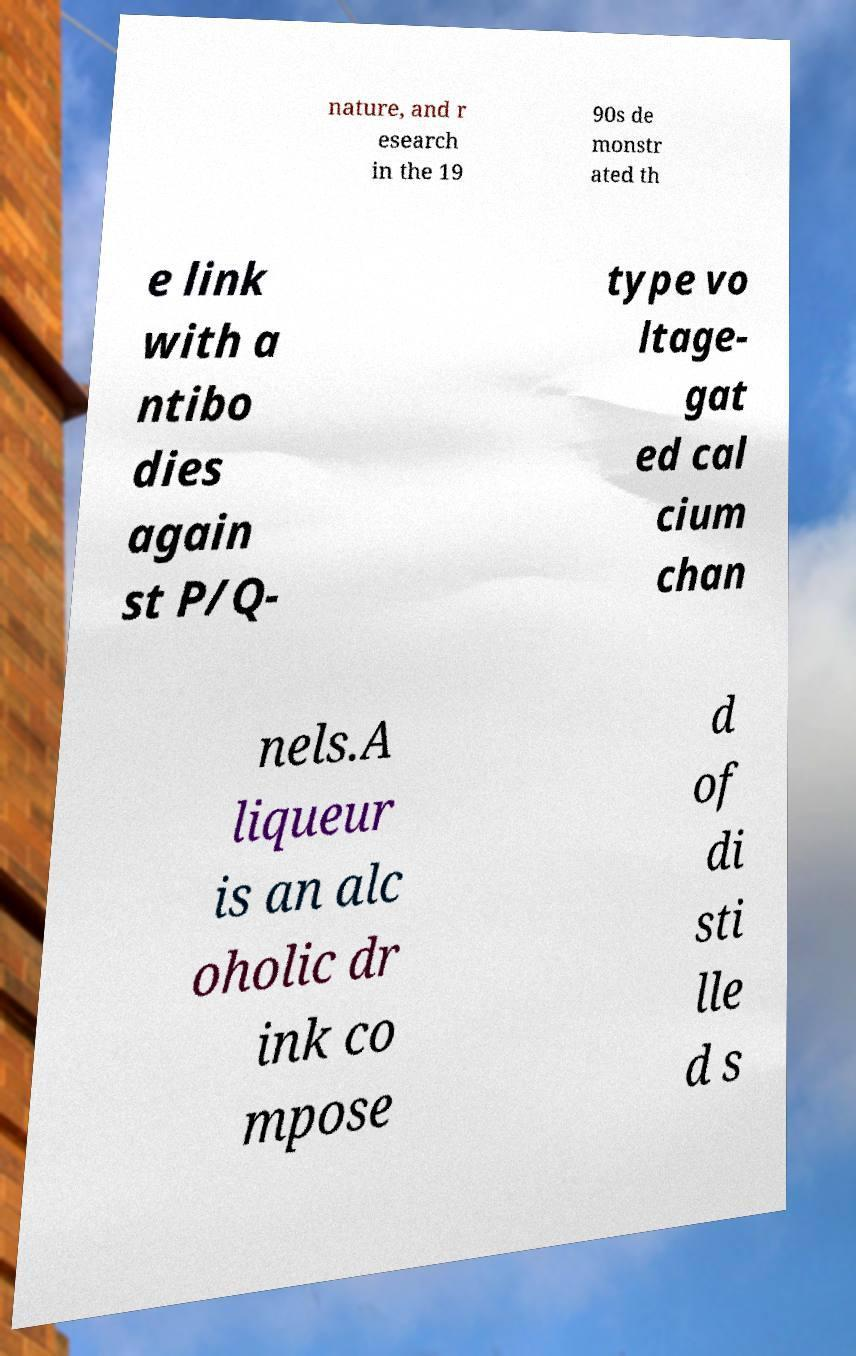Could you assist in decoding the text presented in this image and type it out clearly? nature, and r esearch in the 19 90s de monstr ated th e link with a ntibo dies again st P/Q- type vo ltage- gat ed cal cium chan nels.A liqueur is an alc oholic dr ink co mpose d of di sti lle d s 